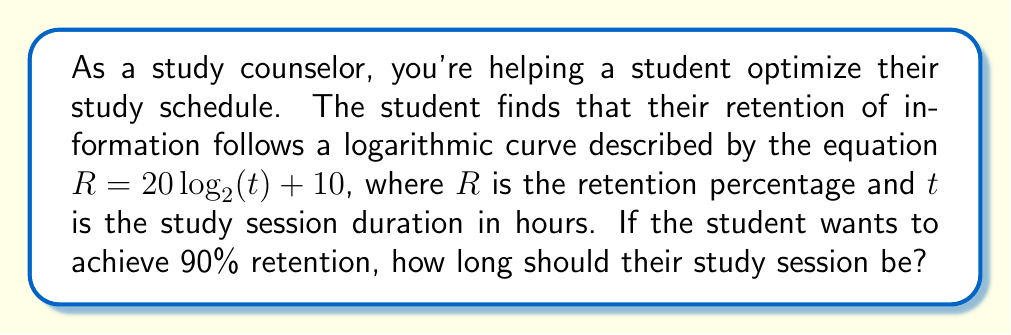Can you answer this question? Let's solve this problem step by step:

1) We start with the equation:
   $R = 20 \log_2(t) + 10$

2) We want to find $t$ when $R = 90$, so let's substitute this:
   $90 = 20 \log_2(t) + 10$

3) Subtract 10 from both sides:
   $80 = 20 \log_2(t)$

4) Divide both sides by 20:
   $4 = \log_2(t)$

5) To solve for $t$, we need to apply the inverse function of $\log_2$, which is $2^x$:
   $2^4 = t$

6) Calculate the result:
   $16 = t$

Therefore, the study session should be 16 hours long to achieve 90% retention according to this model.

Note: In practice, such long continuous study sessions are not recommended. This mathematical model is a simplification and doesn't account for factors like fatigue or diminishing returns. As a counselor, you might suggest breaking this into smaller sessions over multiple days.
Answer: $t = 16$ hours 